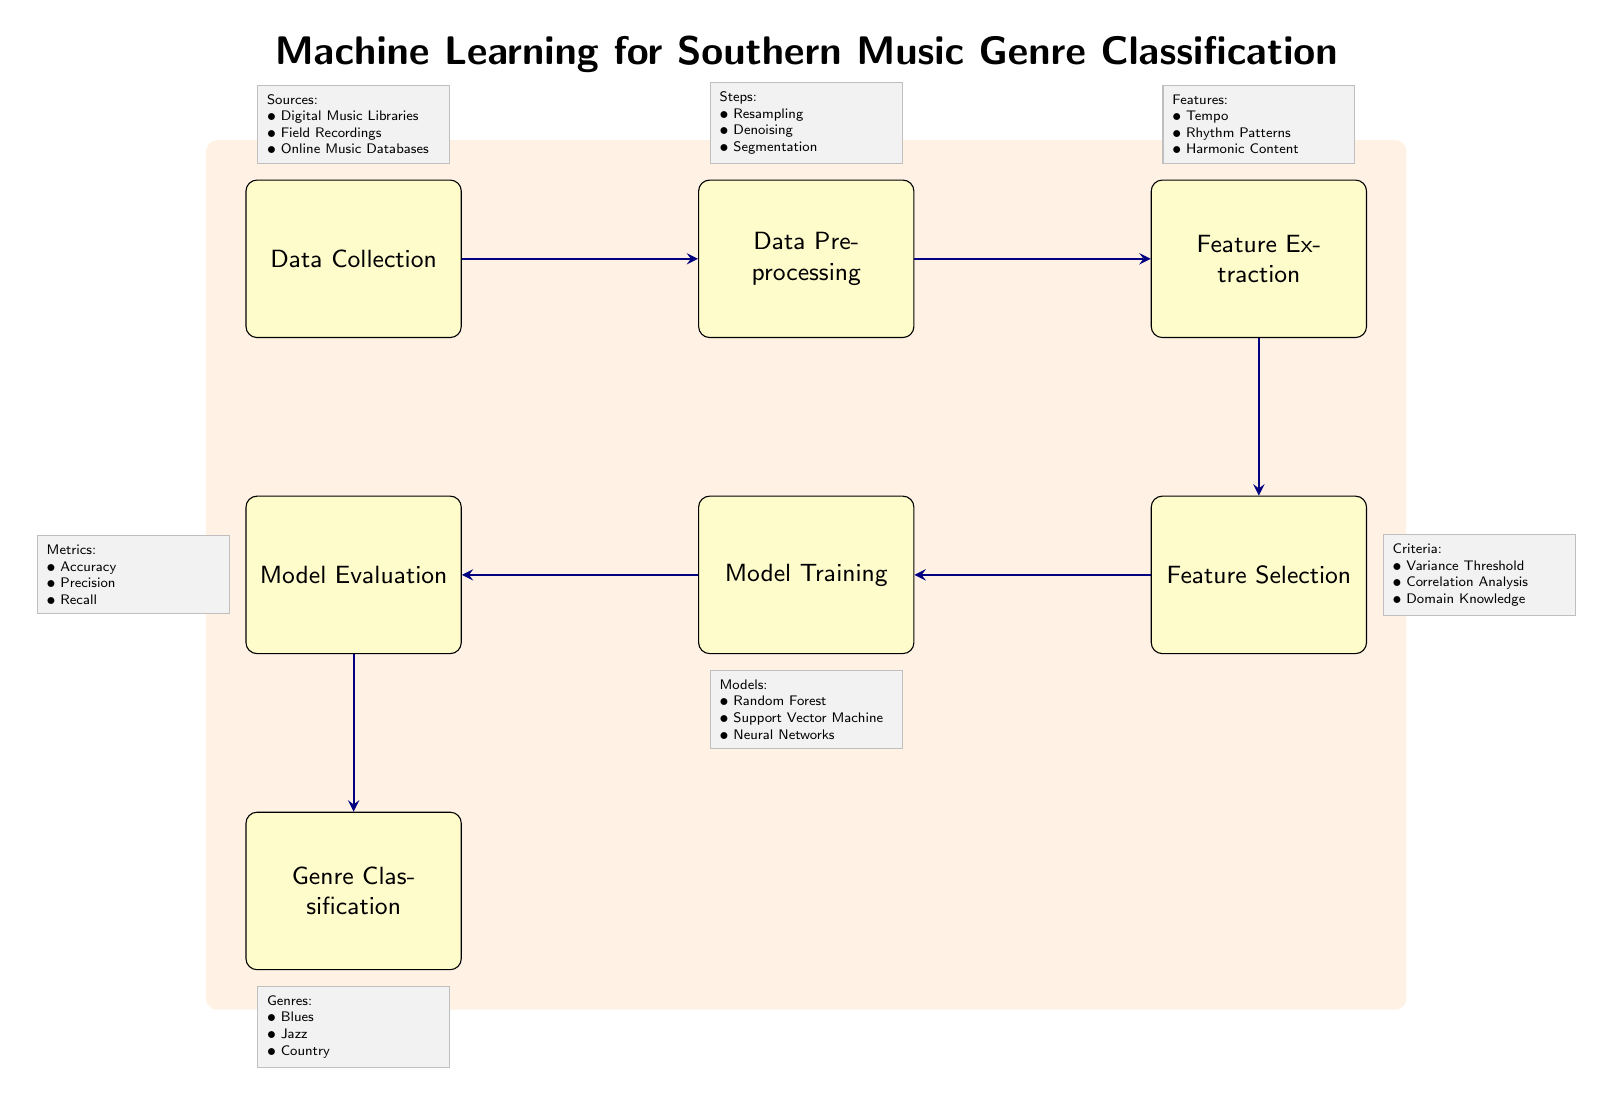What is the first step in the machine learning pipeline? The diagram illustrates that the first step is "Data Collection," which is represented as the leftmost node in the pipeline.
Answer: Data Collection How many models are listed under Model Training? Observing the note next to "Model Training," there are three models mentioned: Random Forest, Support Vector Machine, and Neural Networks.
Answer: Three What types of genres are targeted for classification? The bottom node titled "Genre Classification" includes three specific genres: Blues, Jazz, and Country, which are clearly listed.
Answer: Blues, Jazz, Country What is the last step before Genre Classification? The arrow flow from the "Model Evaluation" node points directly to the "Genre Classification" node, indicating that evaluation is the final step before classifying genres.
Answer: Model Evaluation Which audio features are extracted in the feature extraction step? The note next to "Feature Extraction" lists Tempo, Rhythm Patterns, and Harmonic Content as specific audio features being extracted.
Answer: Tempo, Rhythm Patterns, Harmonic Content What is the purpose of Feature Selection? The criteria for "Feature Selection" include Variance Threshold, Correlation Analysis, and Domain Knowledge, indicating its purpose is to refine the features deemed important for the model.
Answer: Refine important features What metrics are used to evaluate the model? The note next to "Model Evaluation" specifies that Accuracy, Precision, and Recall are the metrics used to assess the model's performance.
Answer: Accuracy, Precision, Recall What step follows Data Preprocessing? The diagram shows an arrow leading from "Data Preprocessing" to "Feature Extraction," indicating that feature extraction happens next in the pipeline.
Answer: Feature Extraction Which data sources are indicated for Data Collection? The note above the "Data Collection" node lists Digital Music Libraries, Field Recordings, and Online Music Databases as the sources of data for collection.
Answer: Digital Music Libraries, Field Recordings, Online Music Databases 